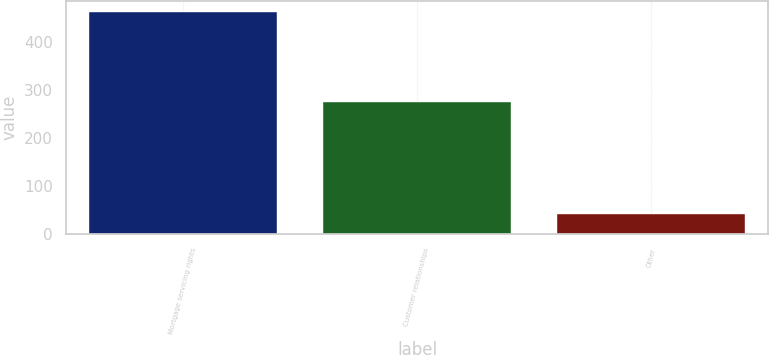Convert chart to OTSL. <chart><loc_0><loc_0><loc_500><loc_500><bar_chart><fcel>Mortgage servicing rights<fcel>Customer relationships<fcel>Other<nl><fcel>462<fcel>275<fcel>42<nl></chart> 